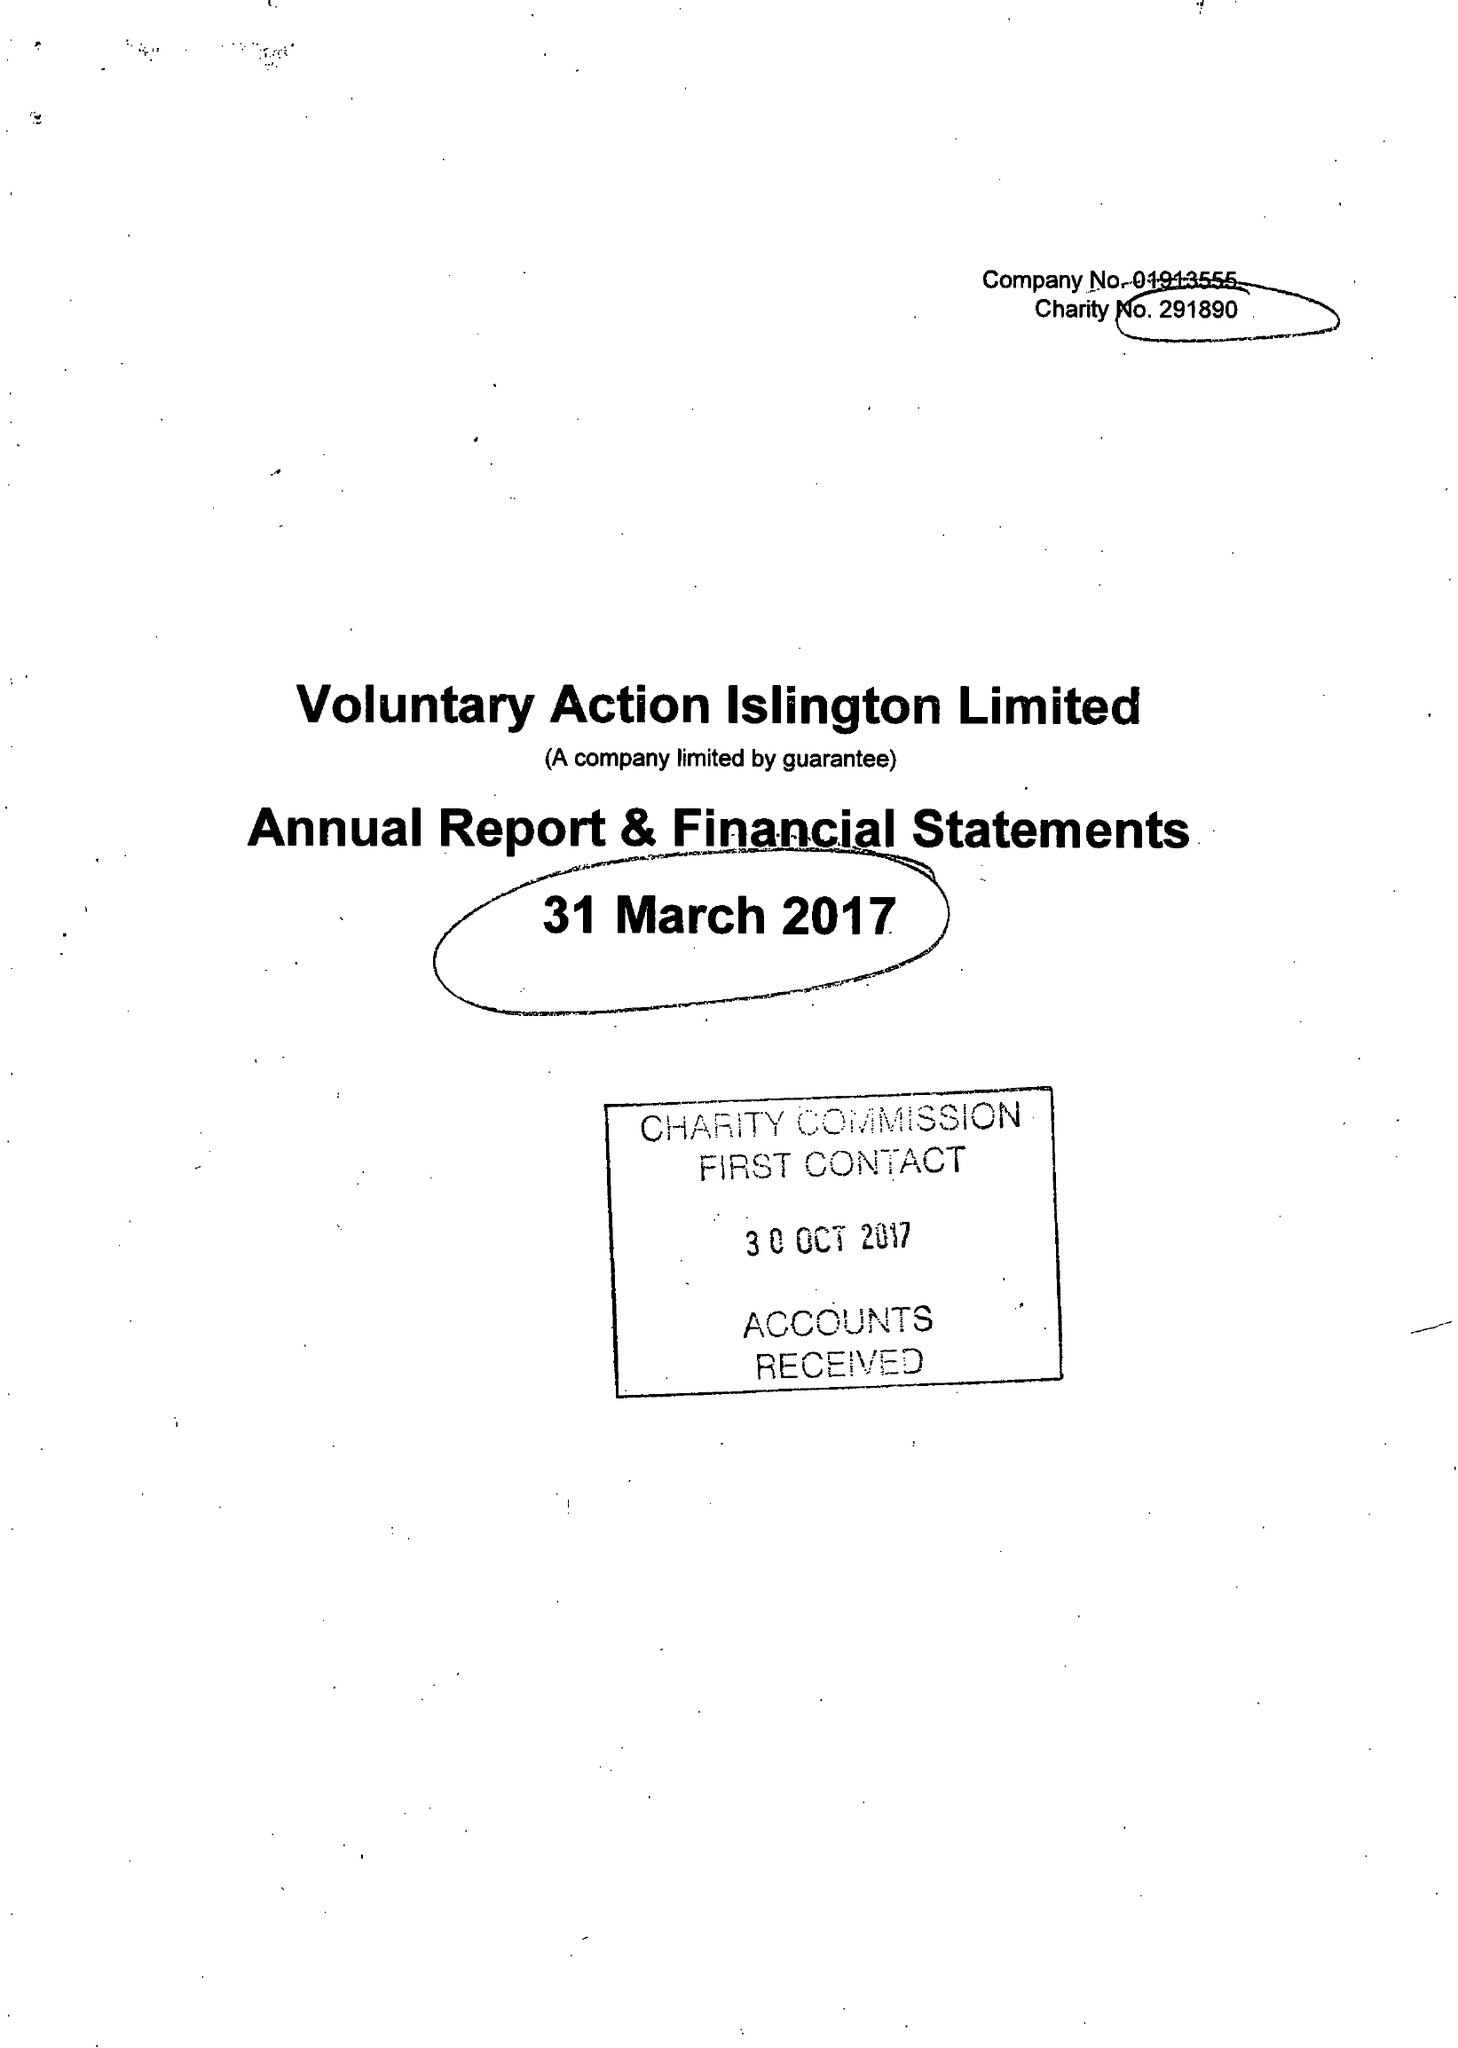What is the value for the charity_name?
Answer the question using a single word or phrase. Voluntary Action Islington Ltd. 